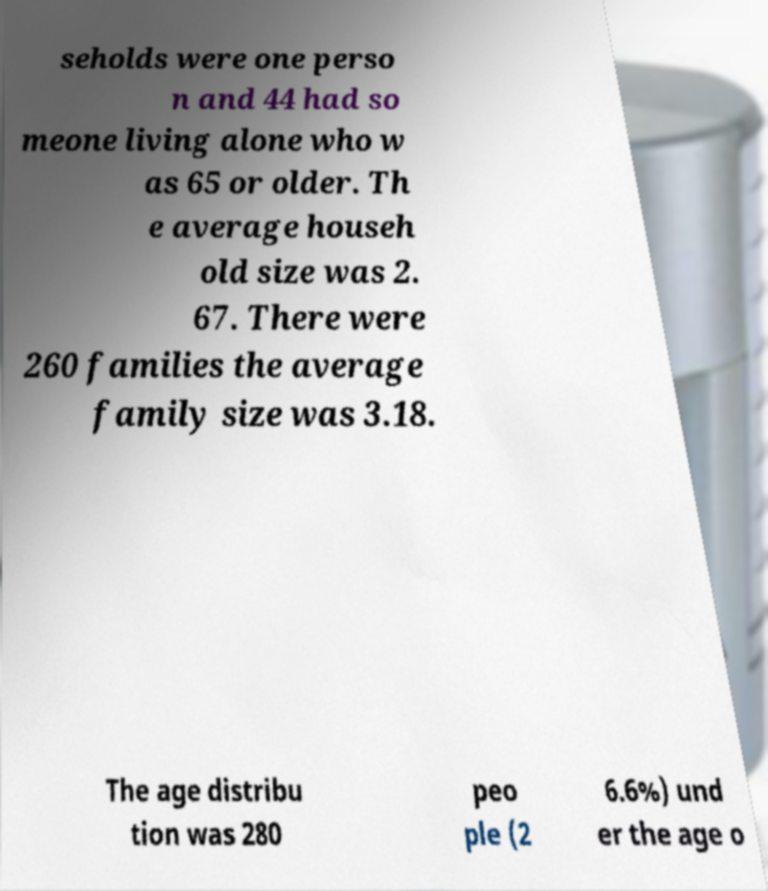Could you assist in decoding the text presented in this image and type it out clearly? seholds were one perso n and 44 had so meone living alone who w as 65 or older. Th e average househ old size was 2. 67. There were 260 families the average family size was 3.18. The age distribu tion was 280 peo ple (2 6.6%) und er the age o 